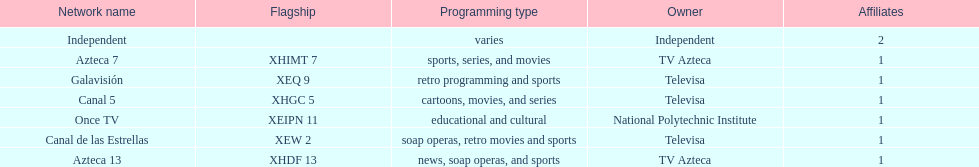Azteca 7 and azteca 13 are both owned by whom? TV Azteca. 